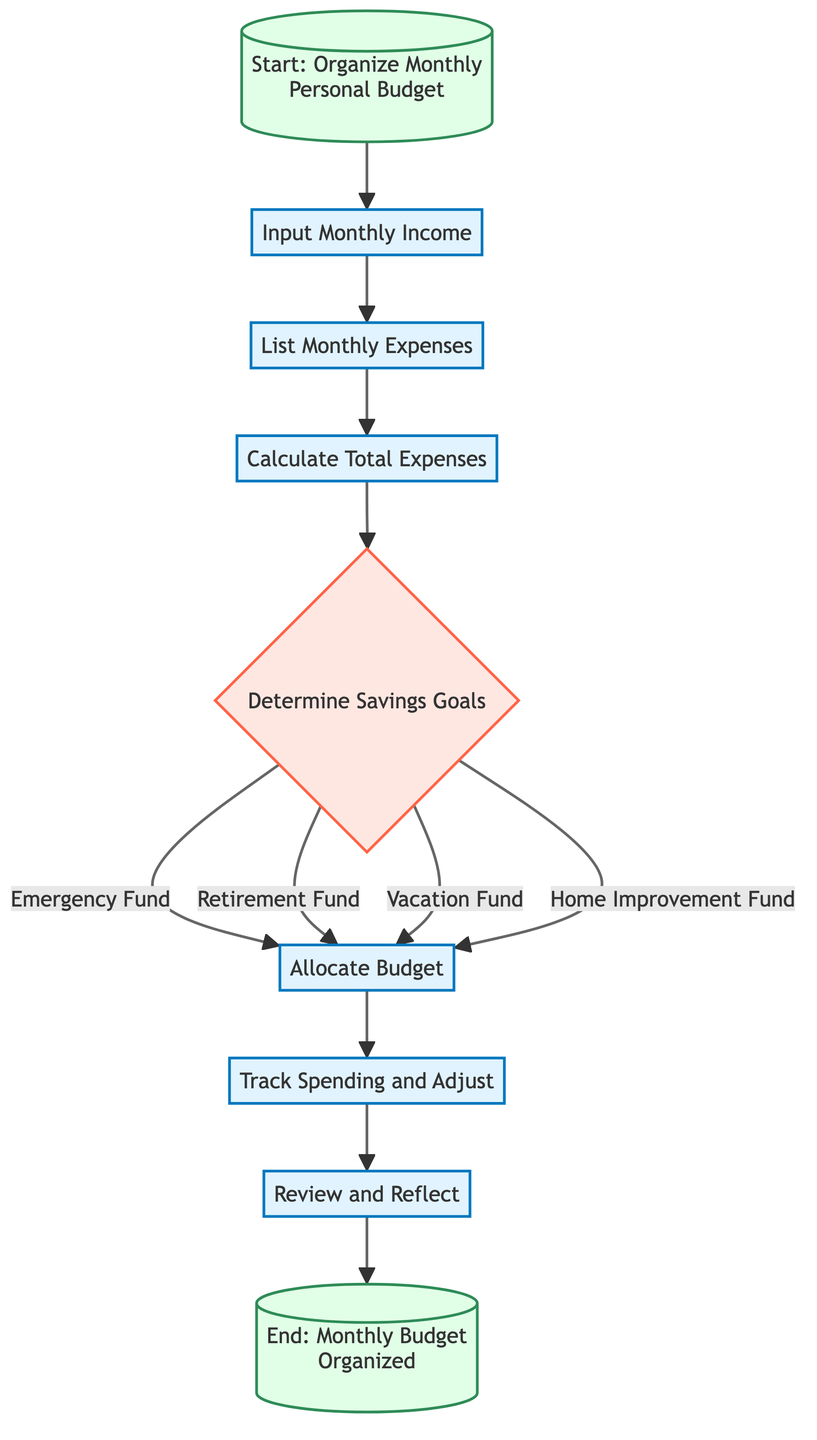What is the first step in the process? The first step in the process, as shown in the diagram, is "Input Monthly Income." This establishes the foundation for organizing the monthly budget.
Answer: Input Monthly Income How many expenses categories are listed? According to the diagram, the step "List Monthly Expenses" includes eight categories: housing, utilities, food, transportation, entertainment, healthcare, debt, and miscellaneous. This counts as eight categories in total.
Answer: Eight What are the savings goals that can be determined? The savings goals indicated in the diagram are "Emergency Fund," "Retirement Fund," "Vacation Fund," and "Home Improvement Fund." These are the four specific goals outlined within the "Determine Savings Goals" step.
Answer: Emergency Fund, Retirement Fund, Vacation Fund, Home Improvement Fund What happens after allocating the budget? After budgeting is allocated, the next step as shown in the diagram is to "Track Spending and Adjust." This implies that monitoring actual expenses against planned budgets is the immediate subsequent action.
Answer: Track Spending and Adjust How many main processes are there before the final review? There are six main processes before reaching the final review in the diagram. They are: "Input Monthly Income," "List Monthly Expenses," "Calculate Total Expenses," "Determine Savings Goals," "Allocate Budget," and "Track Spending and Adjust." This totals to six processes.
Answer: Six Which step follows after determining savings goals? After determining the savings goals, the next step indicated in the flowchart is "Allocate Budget." This means that the identified goals will influence how the budget is distributed.
Answer: Allocate Budget What is the last step in the monthly budget organization? The last step in the monthly budget organization process is "Review and Reflect," marking the conclusion of this budgeting cycle. This stage involves evaluating overall performance against the budget and savings goals.
Answer: Review and Reflect 